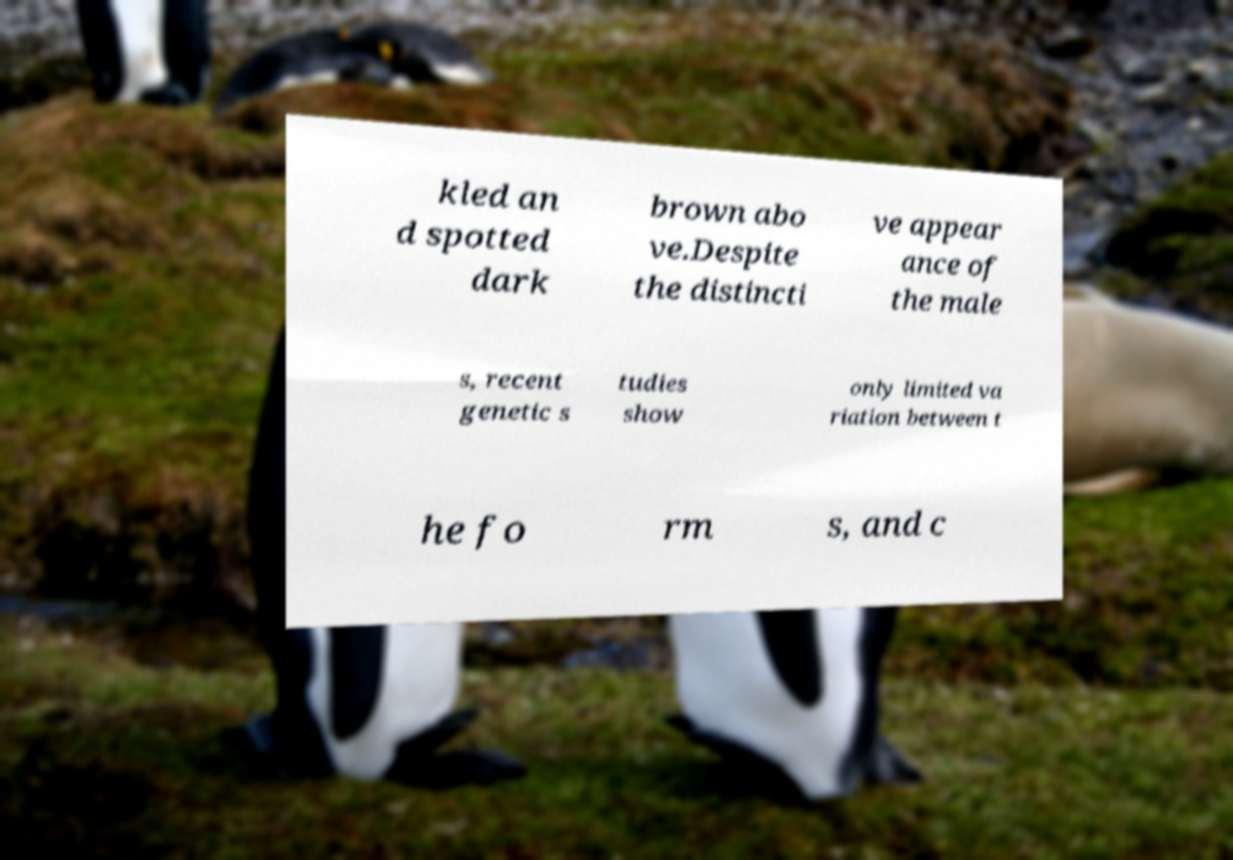Please identify and transcribe the text found in this image. kled an d spotted dark brown abo ve.Despite the distincti ve appear ance of the male s, recent genetic s tudies show only limited va riation between t he fo rm s, and c 